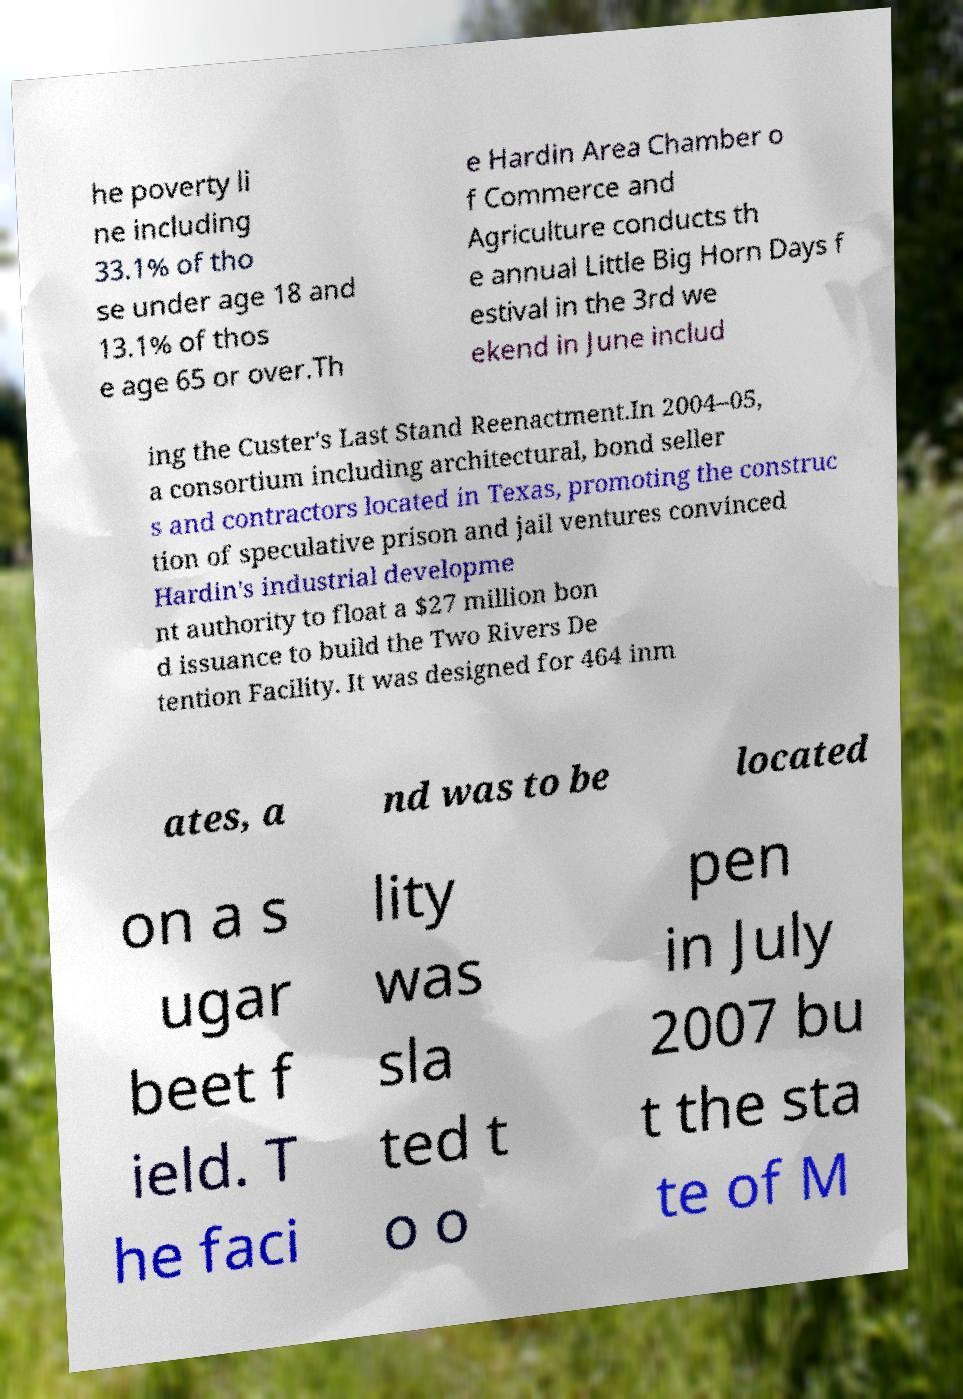I need the written content from this picture converted into text. Can you do that? he poverty li ne including 33.1% of tho se under age 18 and 13.1% of thos e age 65 or over.Th e Hardin Area Chamber o f Commerce and Agriculture conducts th e annual Little Big Horn Days f estival in the 3rd we ekend in June includ ing the Custer's Last Stand Reenactment.In 2004–05, a consortium including architectural, bond seller s and contractors located in Texas, promoting the construc tion of speculative prison and jail ventures convinced Hardin's industrial developme nt authority to float a $27 million bon d issuance to build the Two Rivers De tention Facility. It was designed for 464 inm ates, a nd was to be located on a s ugar beet f ield. T he faci lity was sla ted t o o pen in July 2007 bu t the sta te of M 